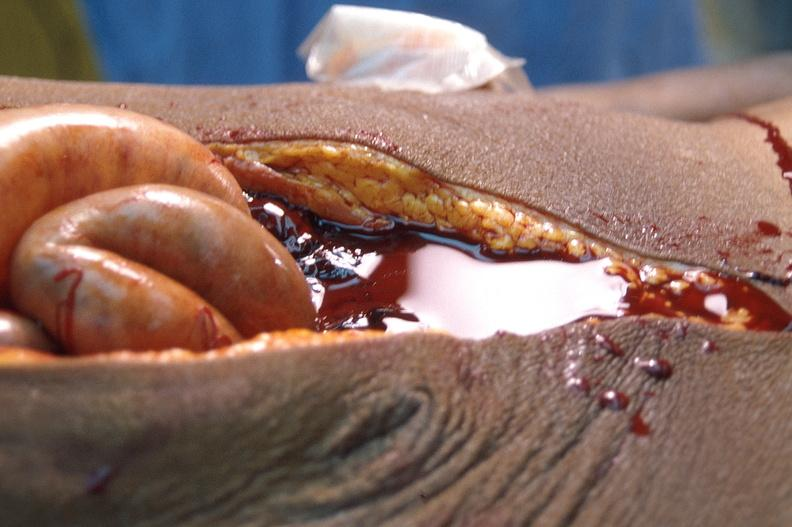s abdomen present?
Answer the question using a single word or phrase. Yes 